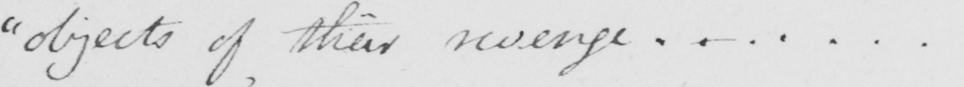Can you read and transcribe this handwriting? " objects of their revenge ...... . 